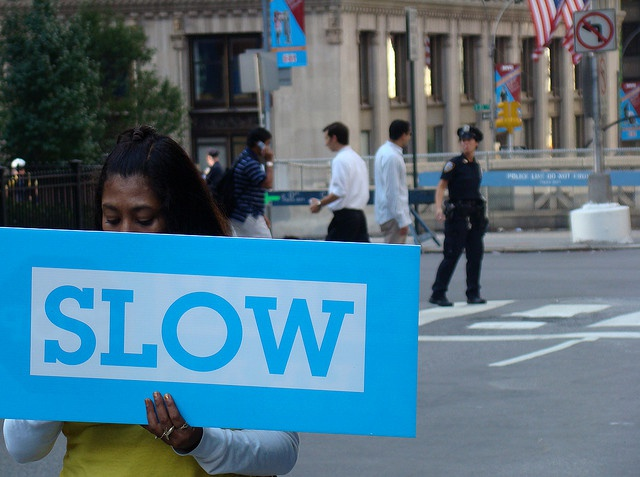Describe the objects in this image and their specific colors. I can see people in gray, black, olive, and maroon tones, people in gray and black tones, people in gray, black, navy, and darkgray tones, people in gray, black, darkgray, and lavender tones, and people in gray, darkgray, and black tones in this image. 